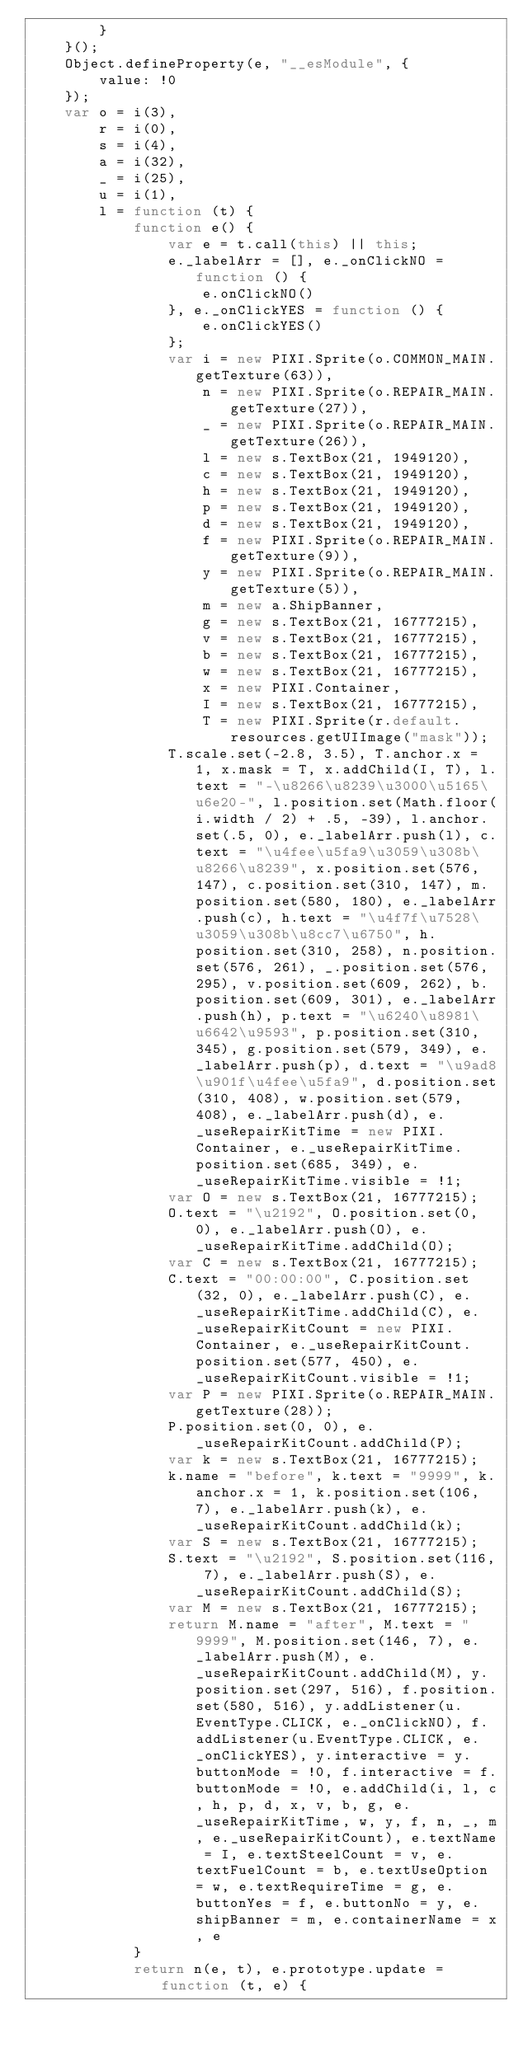<code> <loc_0><loc_0><loc_500><loc_500><_JavaScript_>        }
    }();
    Object.defineProperty(e, "__esModule", {
        value: !0
    });
    var o = i(3),
        r = i(0),
        s = i(4),
        a = i(32),
        _ = i(25),
        u = i(1),
        l = function (t) {
            function e() {
                var e = t.call(this) || this;
                e._labelArr = [], e._onClickNO = function () {
                    e.onClickNO()
                }, e._onClickYES = function () {
                    e.onClickYES()
                };
                var i = new PIXI.Sprite(o.COMMON_MAIN.getTexture(63)),
                    n = new PIXI.Sprite(o.REPAIR_MAIN.getTexture(27)),
                    _ = new PIXI.Sprite(o.REPAIR_MAIN.getTexture(26)),
                    l = new s.TextBox(21, 1949120),
                    c = new s.TextBox(21, 1949120),
                    h = new s.TextBox(21, 1949120),
                    p = new s.TextBox(21, 1949120),
                    d = new s.TextBox(21, 1949120),
                    f = new PIXI.Sprite(o.REPAIR_MAIN.getTexture(9)),
                    y = new PIXI.Sprite(o.REPAIR_MAIN.getTexture(5)),
                    m = new a.ShipBanner,
                    g = new s.TextBox(21, 16777215),
                    v = new s.TextBox(21, 16777215),
                    b = new s.TextBox(21, 16777215),
                    w = new s.TextBox(21, 16777215),
                    x = new PIXI.Container,
                    I = new s.TextBox(21, 16777215),
                    T = new PIXI.Sprite(r.default.resources.getUIImage("mask"));
                T.scale.set(-2.8, 3.5), T.anchor.x = 1, x.mask = T, x.addChild(I, T), l.text = "-\u8266\u8239\u3000\u5165\u6e20-", l.position.set(Math.floor(i.width / 2) + .5, -39), l.anchor.set(.5, 0), e._labelArr.push(l), c.text = "\u4fee\u5fa9\u3059\u308b\u8266\u8239", x.position.set(576, 147), c.position.set(310, 147), m.position.set(580, 180), e._labelArr.push(c), h.text = "\u4f7f\u7528\u3059\u308b\u8cc7\u6750", h.position.set(310, 258), n.position.set(576, 261), _.position.set(576, 295), v.position.set(609, 262), b.position.set(609, 301), e._labelArr.push(h), p.text = "\u6240\u8981\u6642\u9593", p.position.set(310, 345), g.position.set(579, 349), e._labelArr.push(p), d.text = "\u9ad8\u901f\u4fee\u5fa9", d.position.set(310, 408), w.position.set(579, 408), e._labelArr.push(d), e._useRepairKitTime = new PIXI.Container, e._useRepairKitTime.position.set(685, 349), e._useRepairKitTime.visible = !1;
                var O = new s.TextBox(21, 16777215);
                O.text = "\u2192", O.position.set(0, 0), e._labelArr.push(O), e._useRepairKitTime.addChild(O);
                var C = new s.TextBox(21, 16777215);
                C.text = "00:00:00", C.position.set(32, 0), e._labelArr.push(C), e._useRepairKitTime.addChild(C), e._useRepairKitCount = new PIXI.Container, e._useRepairKitCount.position.set(577, 450), e._useRepairKitCount.visible = !1;
                var P = new PIXI.Sprite(o.REPAIR_MAIN.getTexture(28));
                P.position.set(0, 0), e._useRepairKitCount.addChild(P);
                var k = new s.TextBox(21, 16777215);
                k.name = "before", k.text = "9999", k.anchor.x = 1, k.position.set(106, 7), e._labelArr.push(k), e._useRepairKitCount.addChild(k);
                var S = new s.TextBox(21, 16777215);
                S.text = "\u2192", S.position.set(116, 7), e._labelArr.push(S), e._useRepairKitCount.addChild(S);
                var M = new s.TextBox(21, 16777215);
                return M.name = "after", M.text = "9999", M.position.set(146, 7), e._labelArr.push(M), e._useRepairKitCount.addChild(M), y.position.set(297, 516), f.position.set(580, 516), y.addListener(u.EventType.CLICK, e._onClickNO), f.addListener(u.EventType.CLICK, e._onClickYES), y.interactive = y.buttonMode = !0, f.interactive = f.buttonMode = !0, e.addChild(i, l, c, h, p, d, x, v, b, g, e._useRepairKitTime, w, y, f, n, _, m, e._useRepairKitCount), e.textName = I, e.textSteelCount = v, e.textFuelCount = b, e.textUseOption = w, e.textRequireTime = g, e.buttonYes = f, e.buttonNo = y, e.shipBanner = m, e.containerName = x, e
            }
            return n(e, t), e.prototype.update = function (t, e) {</code> 